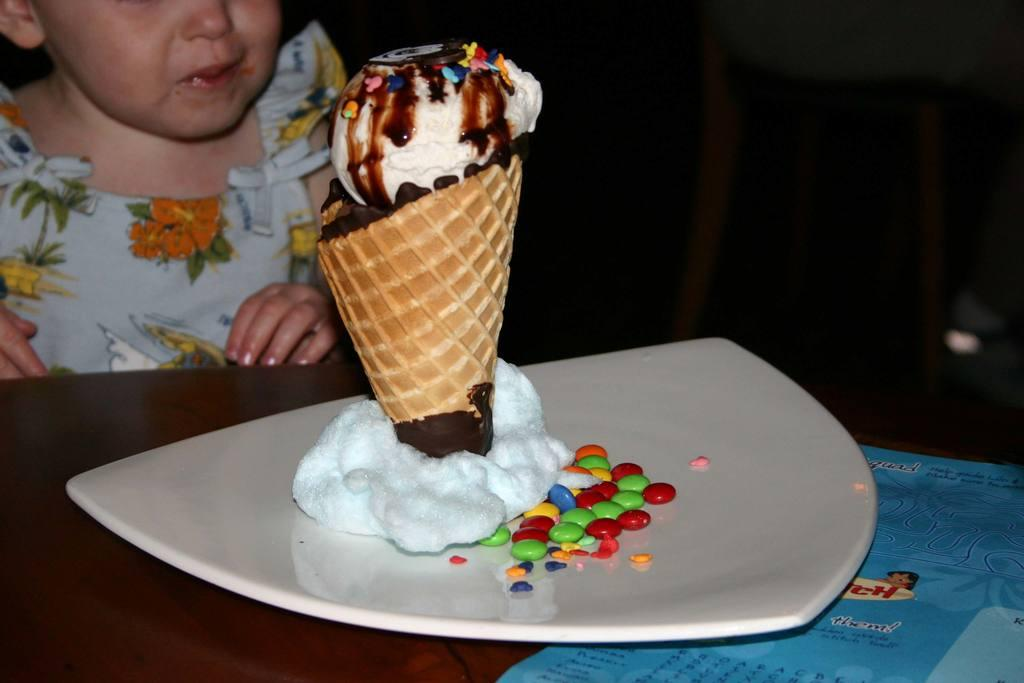What is the main subject of the image? There is a kid in the image. Where is the kid positioned in relation to the table? The kid is in front of a table. What is on the table in the image? There is a paper and a plate on the table. What is in the plate on the table? There are gems and an ice cream in the plate. What type of health issues does the kid have in the image? There is no indication of any health issues in the image; the kid appears to be standing in front of the table. 